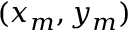Convert formula to latex. <formula><loc_0><loc_0><loc_500><loc_500>( x _ { m } , y _ { m } )</formula> 